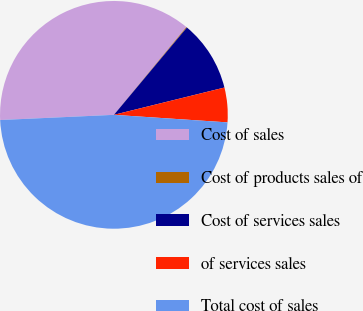<chart> <loc_0><loc_0><loc_500><loc_500><pie_chart><fcel>Cost of sales<fcel>Cost of products sales of<fcel>Cost of services sales<fcel>of services sales<fcel>Total cost of sales<nl><fcel>36.71%<fcel>0.1%<fcel>10.06%<fcel>4.91%<fcel>48.22%<nl></chart> 